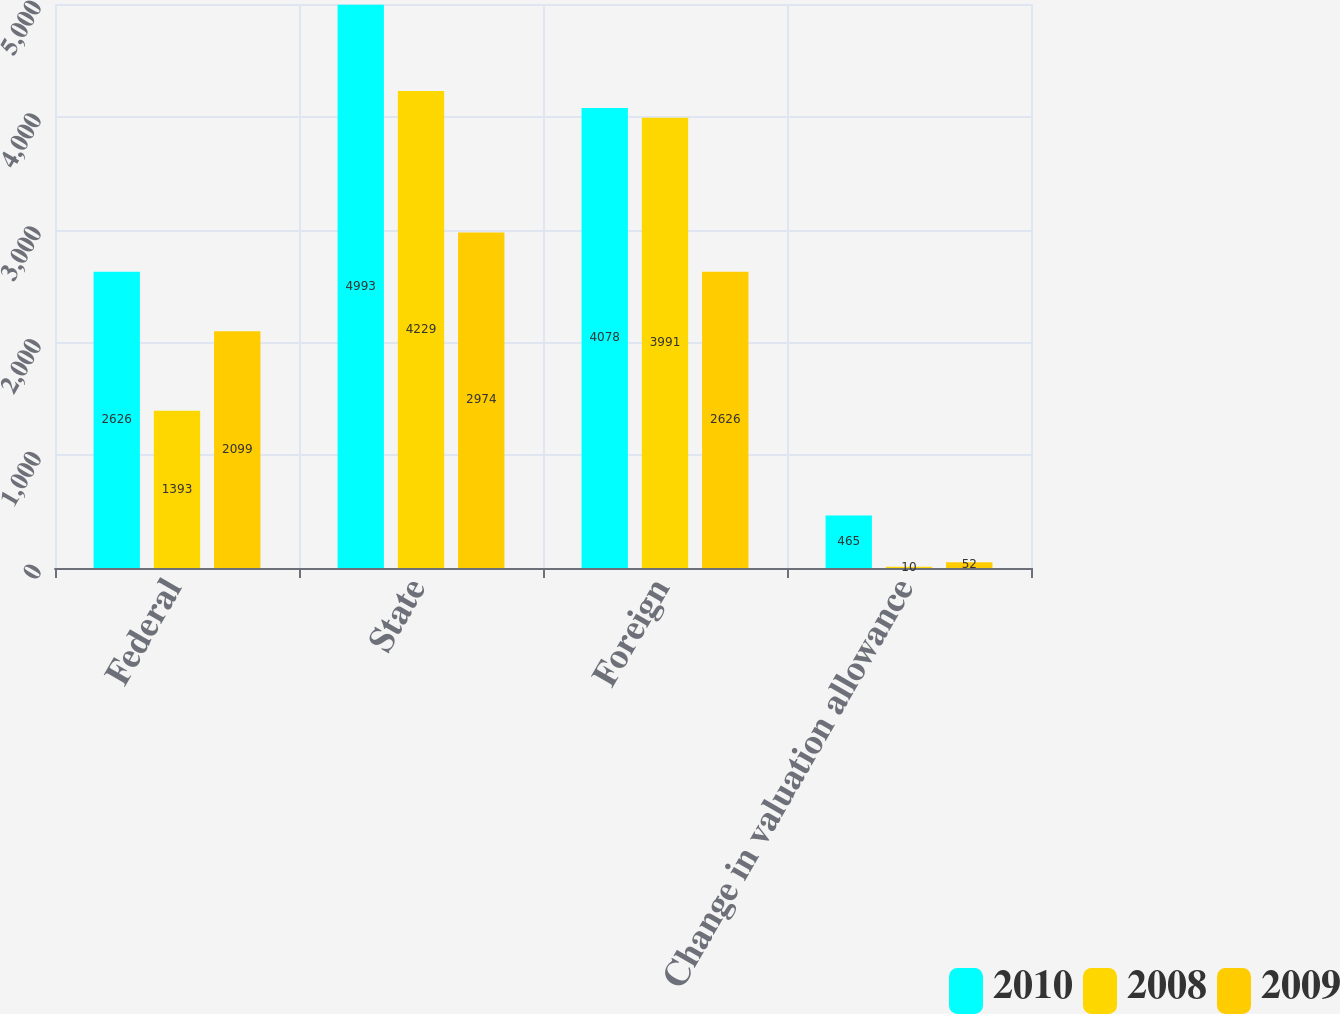Convert chart to OTSL. <chart><loc_0><loc_0><loc_500><loc_500><stacked_bar_chart><ecel><fcel>Federal<fcel>State<fcel>Foreign<fcel>Change in valuation allowance<nl><fcel>2010<fcel>2626<fcel>4993<fcel>4078<fcel>465<nl><fcel>2008<fcel>1393<fcel>4229<fcel>3991<fcel>10<nl><fcel>2009<fcel>2099<fcel>2974<fcel>2626<fcel>52<nl></chart> 